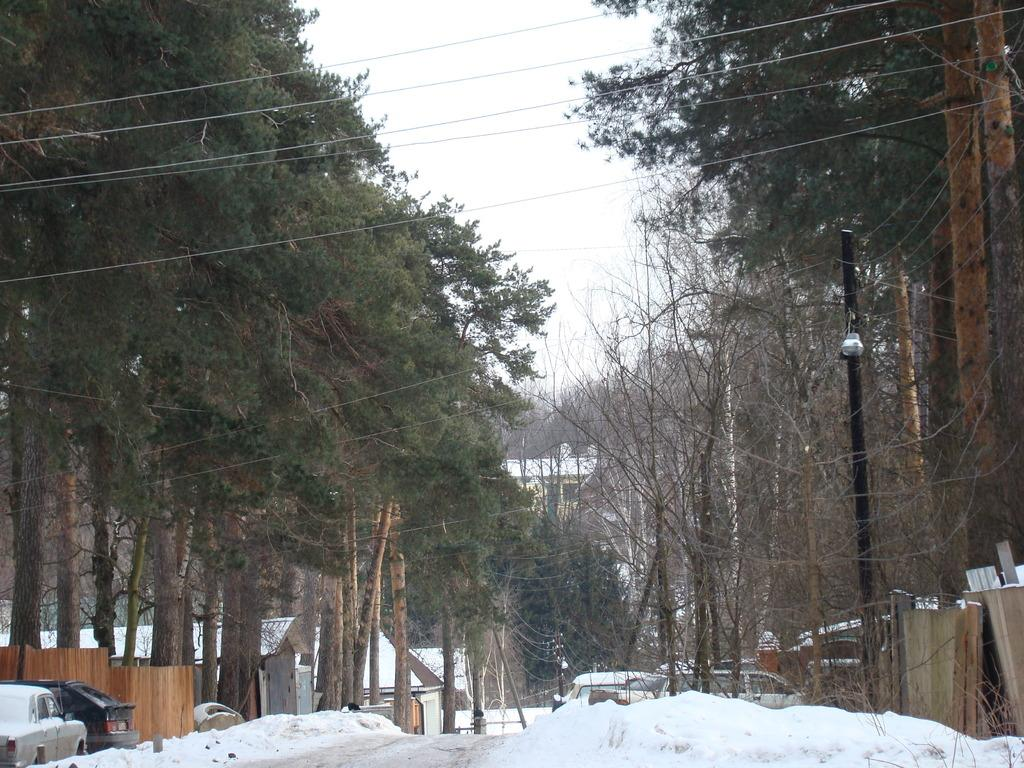What is the condition of the land in the image? The land in the image is covered with snow. What types of objects can be seen on the land? There are vehicles in the image. What natural elements are present in the image? There are trees in the image. What type of structures can be seen in the image? There are houses in the image. What type of spark can be seen coming from the trees in the image? There is no spark present in the image; the trees are covered in snow. How does the image provide pleasure to the viewer? The image itself does not provide pleasure to the viewer; it is a neutral representation of the scene. 